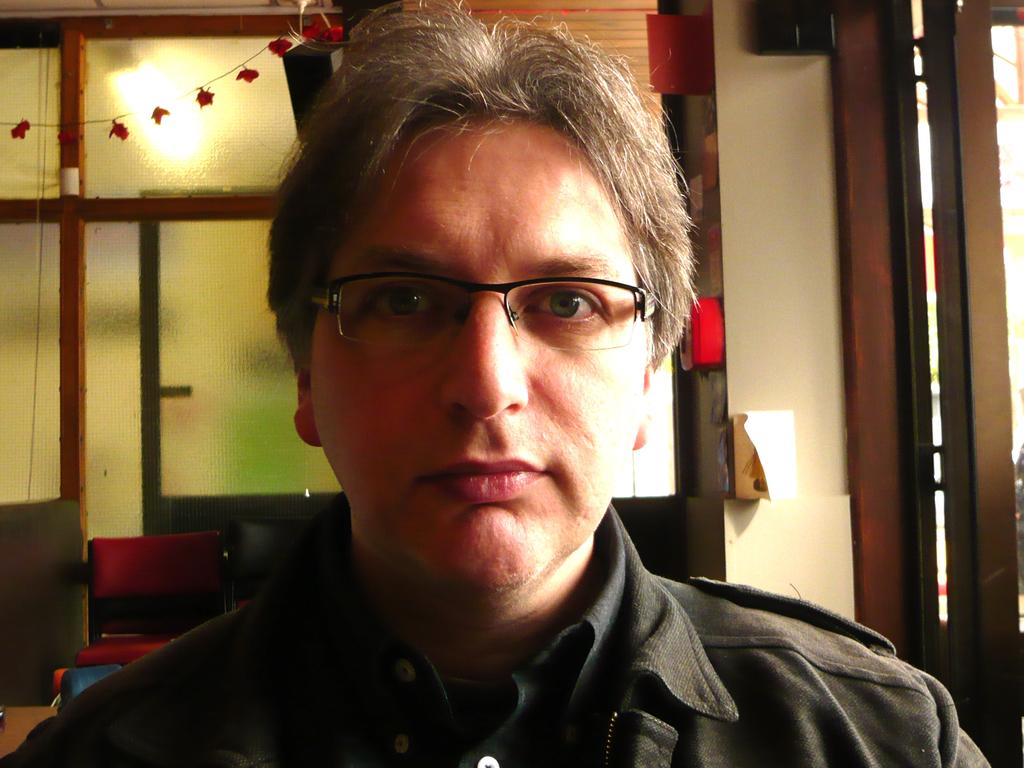Who or what is present in the image? There is a person in the image. What can be seen in the background of the image? There is a wall in the background of the image. What type of furniture is visible in the image? There are chairs in the image. What additional items can be seen in the image? There are decorative items in the image. What type of quiver is visible in the image? There is no quiver present in the image. How does the water affect the pollution in the image? There is no water or pollution present in the image. 